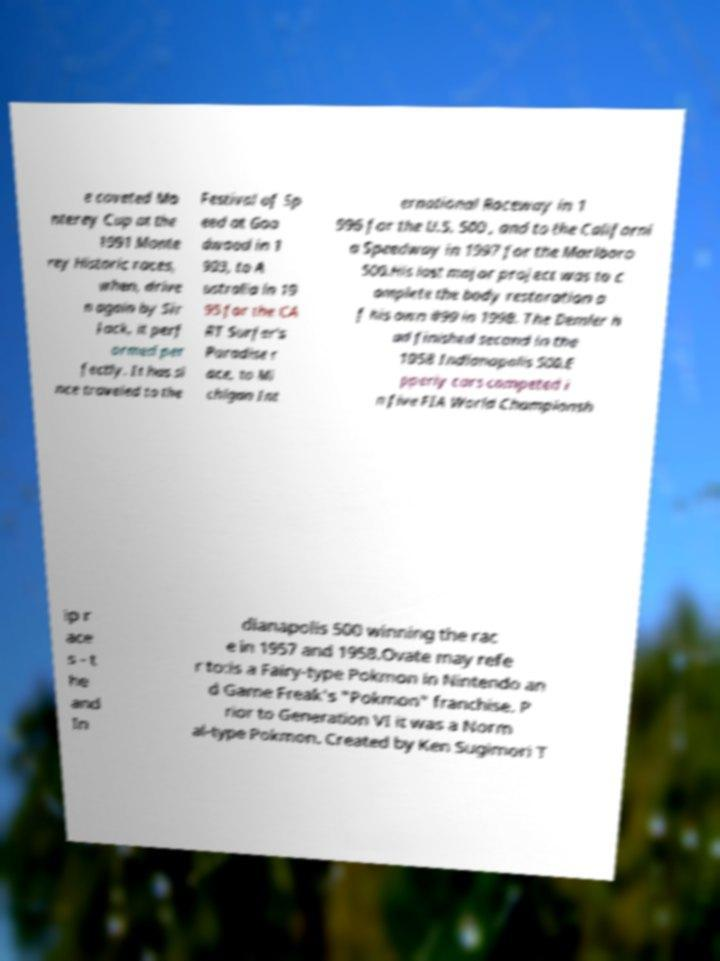For documentation purposes, I need the text within this image transcribed. Could you provide that? e coveted Mo nterey Cup at the 1991 Monte rey Historic races, when, drive n again by Sir Jack, it perf ormed per fectly. It has si nce traveled to the Festival of Sp eed at Goo dwood in 1 993, to A ustralia in 19 95 for the CA RT Surfer's Paradise r ace, to Mi chigan Int ernational Raceway in 1 996 for the U.S. 500 , and to the Californi a Speedway in 1997 for the Marlboro 500.His last major project was to c omplete the body restoration o f his own #99 in 1998. The Demler h ad finished second in the 1958 Indianapolis 500.E pperly cars competed i n five FIA World Championsh ip r ace s - t he and In dianapolis 500 winning the rac e in 1957 and 1958.Ovate may refe r to:is a Fairy-type Pokmon in Nintendo an d Game Freak's "Pokmon" franchise. P rior to Generation VI it was a Norm al-type Pokmon. Created by Ken Sugimori T 